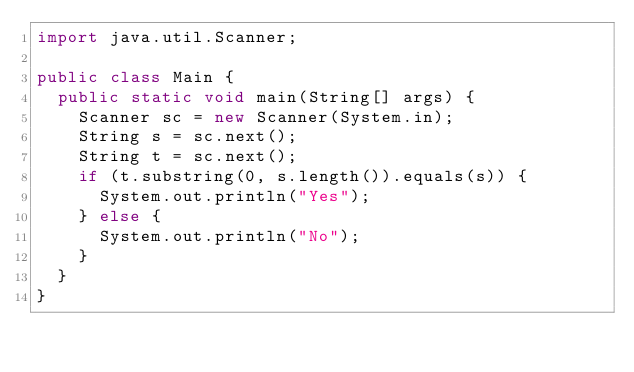<code> <loc_0><loc_0><loc_500><loc_500><_Java_>import java.util.Scanner;

public class Main {
	public static void main(String[] args) {
		Scanner sc = new Scanner(System.in);
		String s = sc.next();
		String t = sc.next();
		if (t.substring(0, s.length()).equals(s)) {
			System.out.println("Yes");
		} else {
			System.out.println("No");
		}
	}
}
</code> 